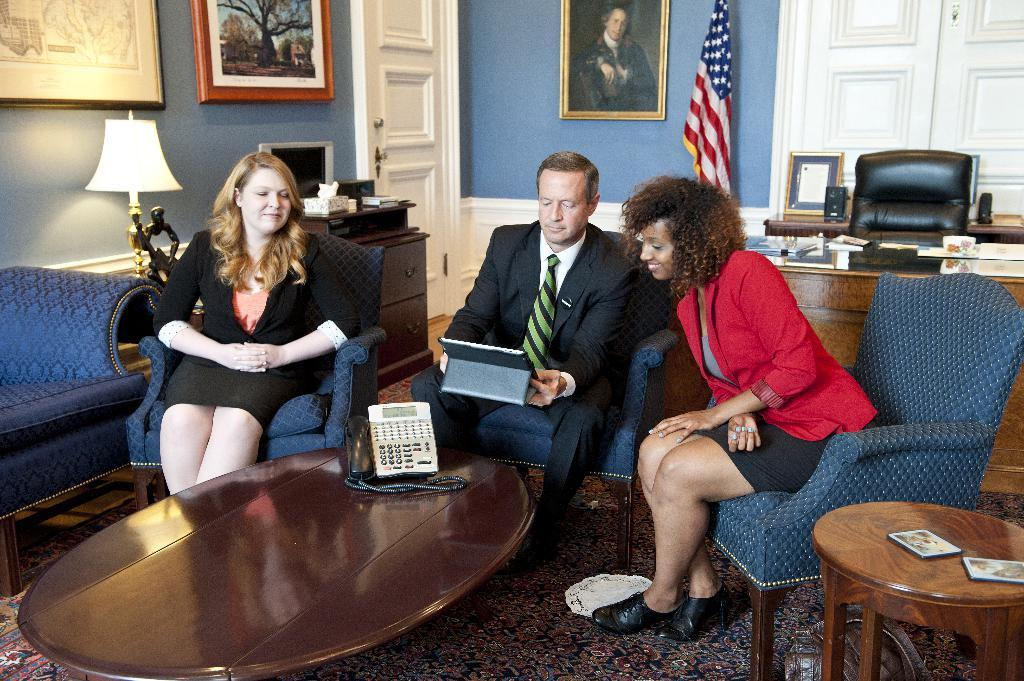How many people are sitting on chairs in the image? There are three people sitting on chairs in the image: two women and one man. What is the man holding in his hand? The man is holding a tab in his hand. What can be seen on the wall in the image? There are frames on the wall. What objects can be seen in the background of the image? There is a lamp, a flag, a table, and a door in the background of the image. What type of fog can be seen in the image? There is no fog present in the image. What reward is the man receiving for his actions in the image? There is no indication in the image that the man is receiving a reward for any actions. 